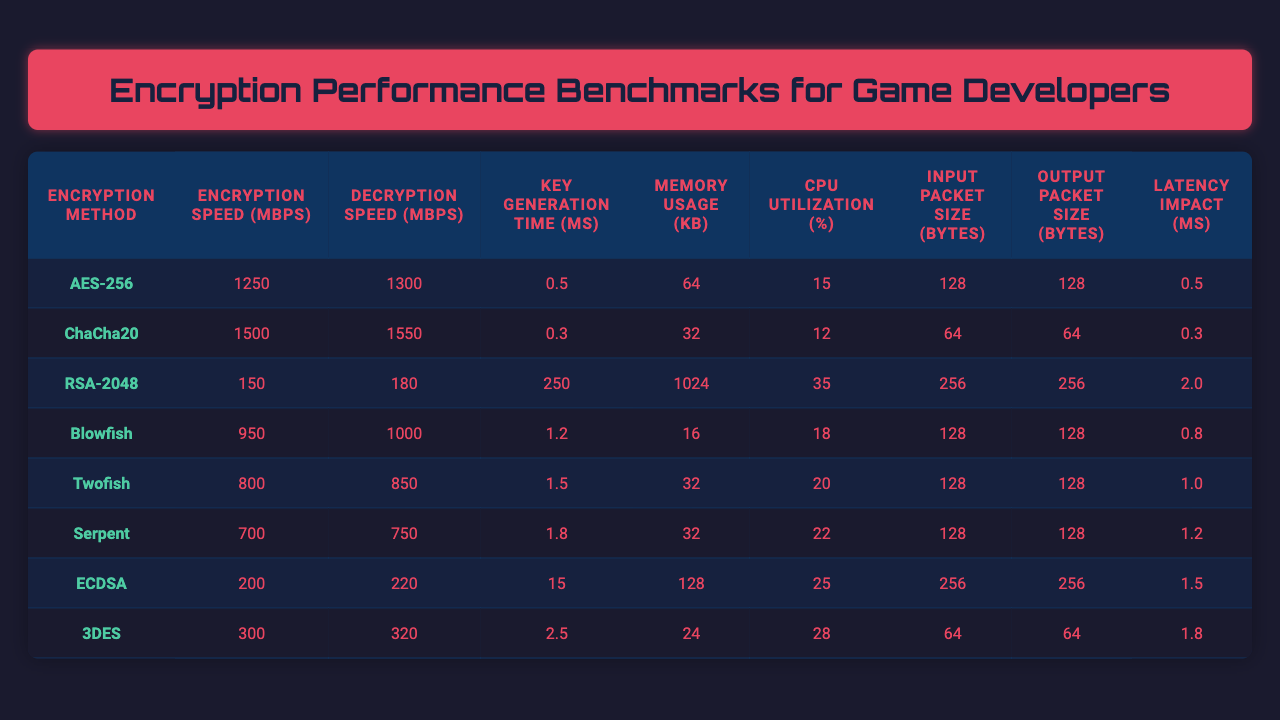What is the encryption speed of AES-256 on Windows PC? The table shows that the encryption speed of AES-256 on Windows PC is 1250 Mbps.
Answer: 1250 Mbps Which encryption method has the highest decryption speed on PlayStation 5? According to the table, ChaCha20 has the highest decryption speed of 1550 Mbps on PlayStation 5.
Answer: ChaCha20 What is the difference in key generation time between RSA-2048 and Blowfish? The key generation time for RSA-2048 is 250 ms and for Blowfish, it is 1.2 ms. The difference is 250 ms - 1.2 ms = 248.8 ms.
Answer: 248.8 ms Which encryption method uses the least memory? By reviewing the memory usage column, Blowfish uses the least memory at 16 KB.
Answer: 16 KB What is the average encryption speed across all listed methods? The encryption speeds are 1250, 1500, 150, 950, 800, 700, 200, and 300 Mbps. Summing them gives 1250 + 1500 + 150 + 950 + 800 + 700 + 200 + 300 = 4850 Mbps. Dividing by 8 (the number of methods) results in an average of 4850 / 8 = 606.25 Mbps.
Answer: 606.25 Mbps Which encryption method has the highest CPU utilization, and what is that percentage? Scanning the CPU utilization column, RSA-2048 shows the highest CPU utilization at 35%.
Answer: RSA-2048, 35% Is the latency impact of ChaCha20 lower than that of Twofish? The latency impact for ChaCha20 is 0.3 ms, while for Twofish it is 1.0 ms. Since 0.3 ms is less than 1.0 ms, the statement is true.
Answer: Yes What is the total memory usage for all encryption methods combined? Adding the memory usage values gives: 64 + 32 + 1024 + 16 + 32 + 32 + 128 + 24 = 1324 KB total memory usage.
Answer: 1324 KB Find the method with the lowest decryption speed and specify the speed. The table shows that RSA-2048 has the lowest decryption speed at 180 Mbps.
Answer: RSA-2048, 180 Mbps Are the input and output packet sizes the same for AES-256? Checking the corresponding columns for AES-256, both input and output packet sizes are 128 bytes, confirming they are the same.
Answer: Yes 